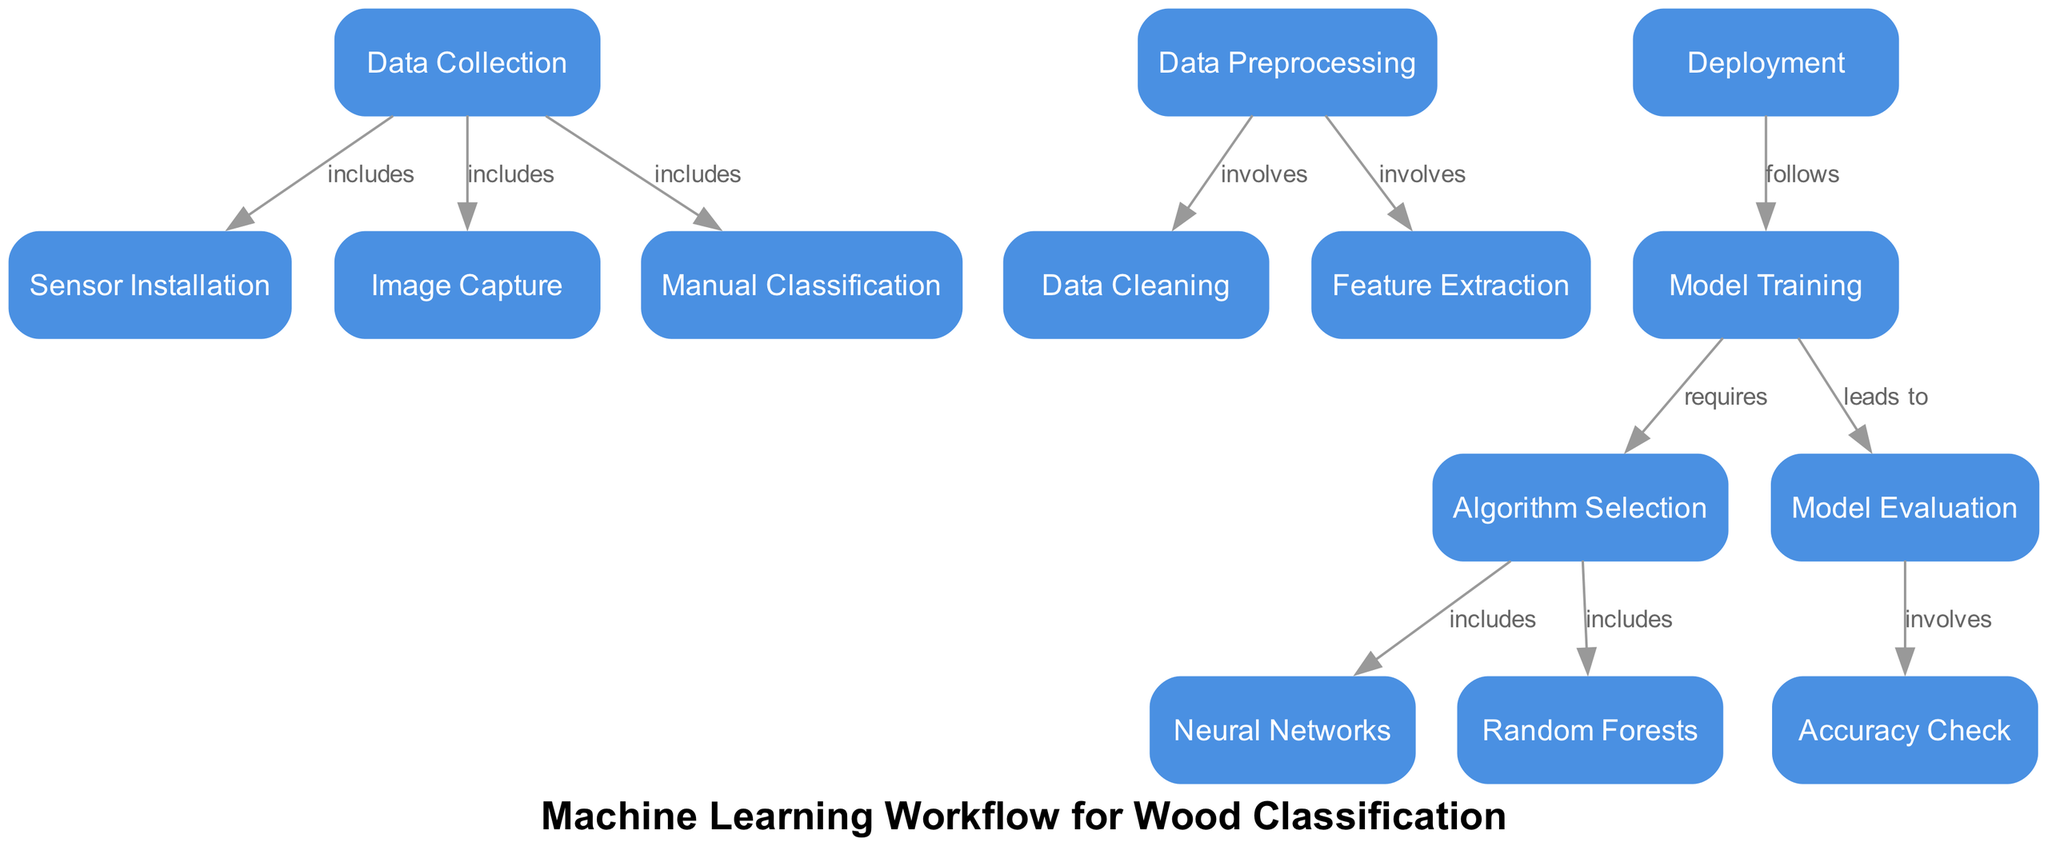What is the first node in the diagram? The diagram begins with the "Data Collection" node, which represents the initial step in the machine learning workflow for wood classification.
Answer: Data Collection How many types of algorithms are included in the model training phase? During the model training phase, the diagram includes two types of algorithms: "Neural Networks" and "Random Forests", which are derived from the "Algorithm Selection" node.
Answer: Two What is the relationship between the data cleaning and feature extraction nodes? The diagram shows that both "Data Cleaning" and "Feature Extraction" are involved in the "Data Preprocessing" step, indicating that they are subprocesses that prepare the data before training the model.
Answer: Involved Which node leads to the accuracy check? The "Model Evaluation" node leads to the "Accuracy Check" node, indicating that checking accuracy is a part of evaluating the model's performance after it has been trained.
Answer: Model Evaluation What process follows the deployment phase? According to the diagram, the "Model Training" follows the "Deployment" phase, signifying that after a model is deployed, it can lead to further training, potentially to improve its performance or adapt to new input data.
Answer: Model Training Which nodes are directly connected to sensor installation? The "Data Collection" node is directly connected to "Sensor Installation", signifying that sensor installation is part of the data collection process for the machine learning project.
Answer: Data Collection Explain how many edges are shown connecting nodes within data preprocessing. Within "Data Preprocessing," there are two edges connecting to the nodes "Data Cleaning" and "Feature Extraction", representing the activities that occur as part of the preprocessing step.
Answer: Two What is the final step after the model evaluation? The final step after "Model Evaluation" is "Accuracy Check", which indicates that assessing the model's accuracy is a concluding phase of evaluation in the machine learning workflow.
Answer: Accuracy Check What node comes after algorithm selection? After "Algorithm Selection", the workflow proceeds to "Model Training", which involves using the selected algorithms to build the model based on the provided data.
Answer: Model Training 